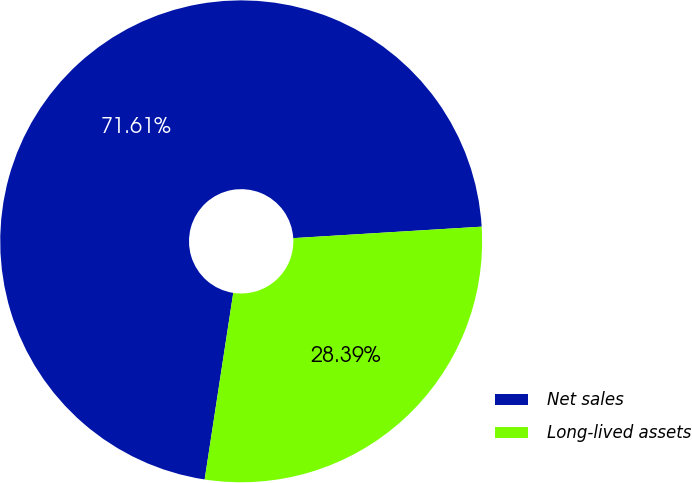<chart> <loc_0><loc_0><loc_500><loc_500><pie_chart><fcel>Net sales<fcel>Long-lived assets<nl><fcel>71.61%<fcel>28.39%<nl></chart> 